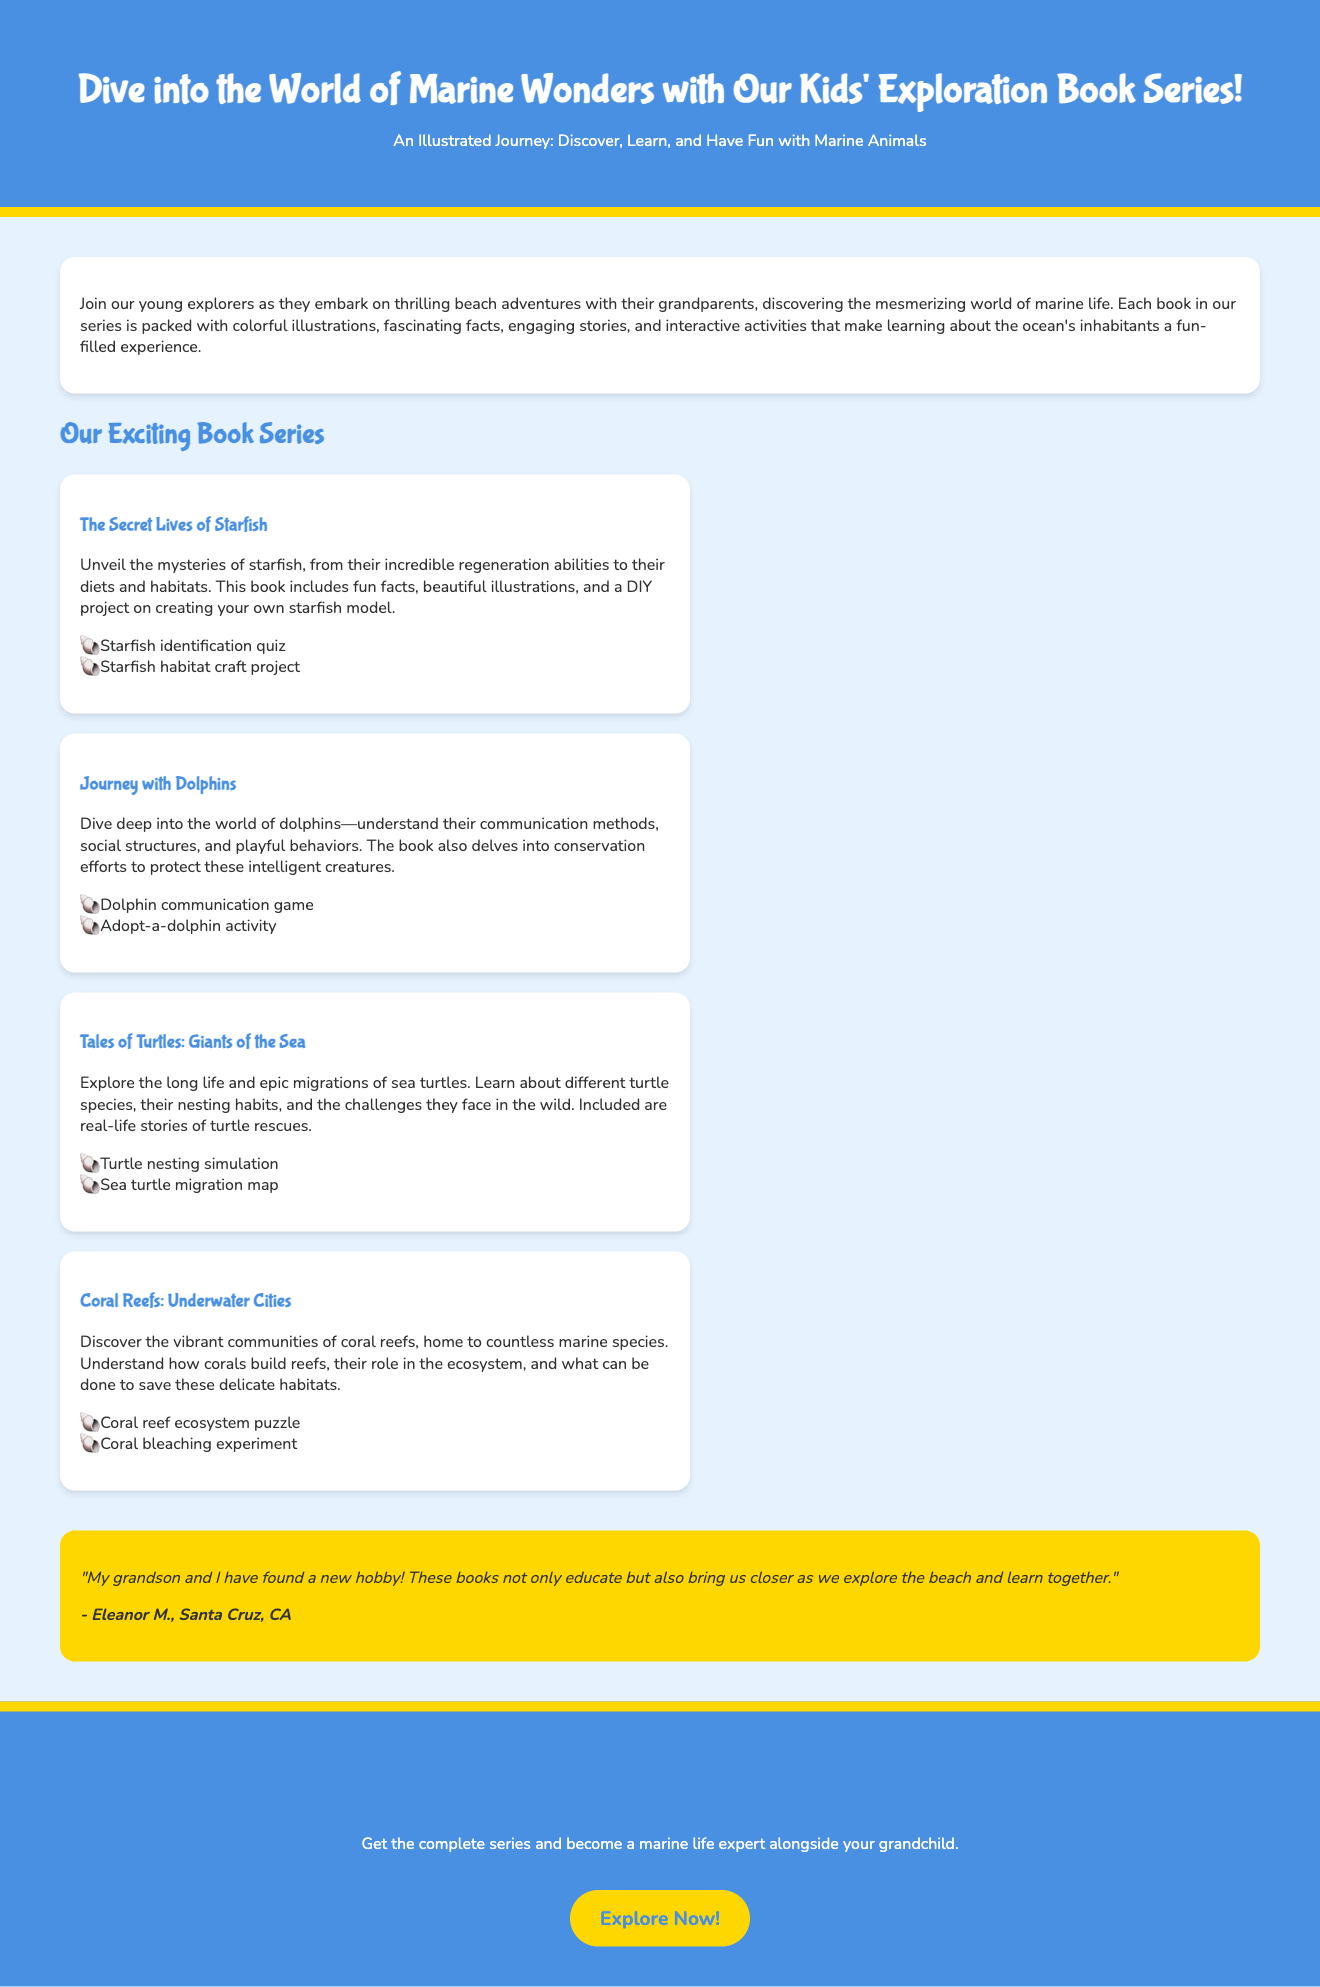What is the title of the book series? The title of the book series is mentioned at the beginning of the document, which is "Marine Life Exploration Book Series for Kids."
Answer: Marine Life Exploration Book Series for Kids How many books are in the series? The document describes four different books, highlighting the topics of each, which indicates a total of four books in the series.
Answer: Four What is the focus of the book "Journey with Dolphins"? The focus is described in the content under this book, which emphasizes understanding dolphins' communication methods and social structures.
Answer: Communication methods and social structures What interactive activity is included in "The Secret Lives of Starfish"? The document lists interactive elements for each book; one activity for this book is a "starfish identification quiz."
Answer: Starfish identification quiz Who provided a testimonial for the book series? The testimonial is attributed to Eleanor M. from Santa Cruz, CA, who shares her experience with the books.
Answer: Eleanor M What is the background color of the document? The background color is specified in the CSS styles within the document, which states it is a light blue color.
Answer: Light blue What is the call to action at the end of the document? The call to action is to encourage readers to start their marine adventure and provides a link for purchasing the books.
Answer: Explore Now! What type of content is included in each book? The description of each book mentions that they are packed with colorful illustrations, fascinating facts, engaging stories, and interactive activities.
Answer: Colorful illustrations, fascinating facts, engaging stories, and interactive activities 